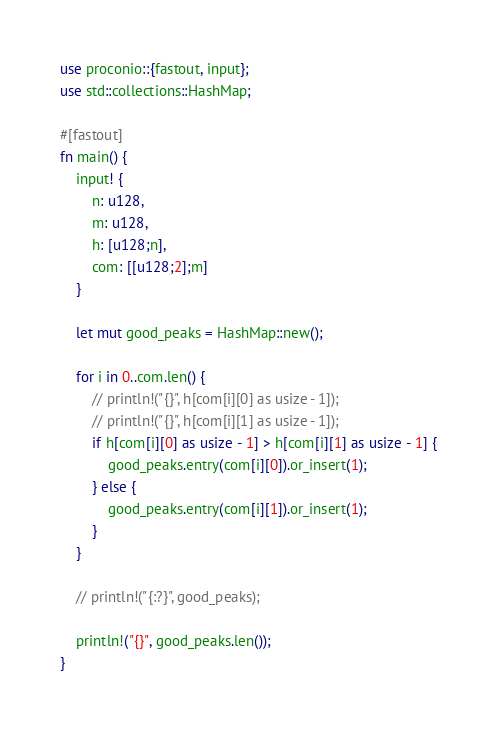<code> <loc_0><loc_0><loc_500><loc_500><_Rust_>use proconio::{fastout, input};
use std::collections::HashMap;

#[fastout]
fn main() {
    input! {
        n: u128,
        m: u128,
        h: [u128;n],
        com: [[u128;2];m]
    }

    let mut good_peaks = HashMap::new();

    for i in 0..com.len() {
        // println!("{}", h[com[i][0] as usize - 1]);
        // println!("{}", h[com[i][1] as usize - 1]);
        if h[com[i][0] as usize - 1] > h[com[i][1] as usize - 1] {
            good_peaks.entry(com[i][0]).or_insert(1);
        } else {
            good_peaks.entry(com[i][1]).or_insert(1);
        }
    }

    // println!("{:?}", good_peaks);

    println!("{}", good_peaks.len());
}
</code> 